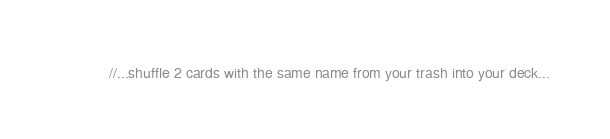Convert code to text. <code><loc_0><loc_0><loc_500><loc_500><_C#_>            //...shuffle 2 cards with the same name from your trash into your deck...</code> 